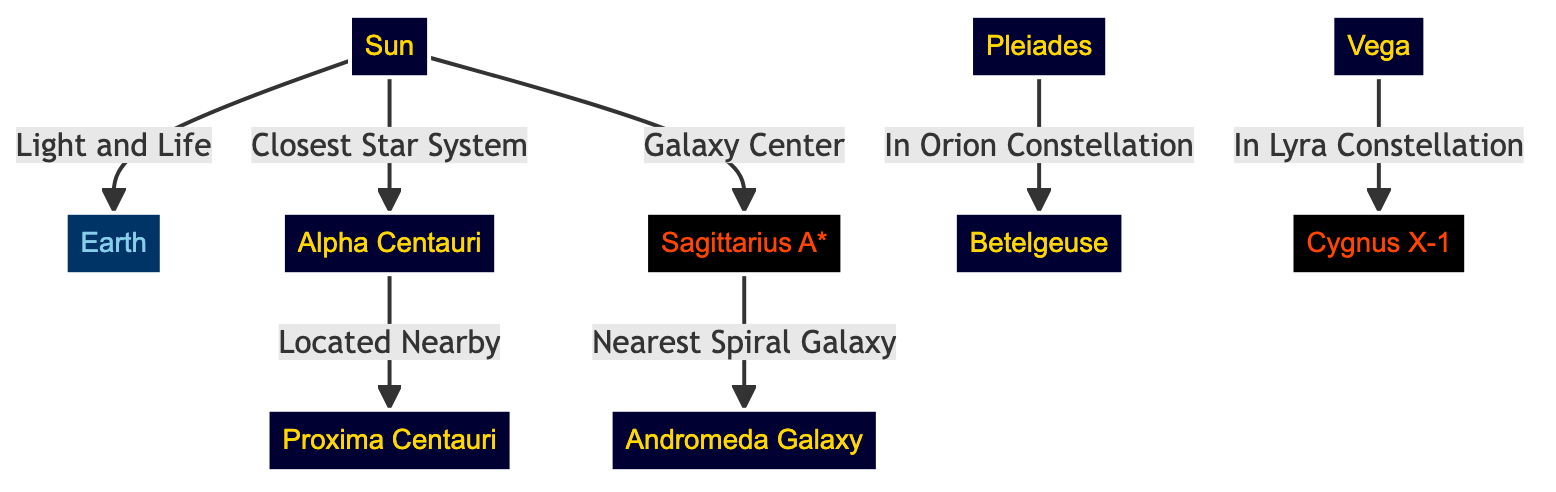What is at the center of the Milky Way? The diagram indicates that Sagittarius A* is the central object of the Milky Way, as shown by its direct connection to the Sun labeled "Galaxy Center." Therefore, the answer can be directly identified from this relationship.
Answer: Sagittarius A* Which celestial object is the closest star system to the Sun? In the diagram, Alpha Centauri is clearly connected to the Sun with the label "Closest Star System," indicating it is the nearest star system. Thus, the answer follows from that connection.
Answer: Alpha Centauri How many celestial landmarks are connected to the Sun? By analyzing the diagram visually, we can see that the Sun is linked to three distinct celestial landmarks: Earth, Alpha Centauri, and Sagittarius A*. Counting these connections gives us the total number of connections.
Answer: 3 What constellation is Betelgeuse part of? The diagram explicitly states that Betelgeuse is in the Orion Constellation, as shown in the connection labeled "In Orion Constellation". This can be directly noted from the information provided in the diagram.
Answer: Orion What is the relationship between Alpha Centauri and Proxima Centauri? The diagram illustrates that Alpha Centauri is "Located Nearby" to Proxima Centauri, indicating a close spatial relationship between the two star systems. Analyzing this connection gives us the nature of their relationship.
Answer: Located Nearby Which celestial body is described as the "Nearest Spiral Galaxy"? The diagram clearly connects Sagittarius A* to Andromeda with the label "Nearest Spiral Galaxy," making it evident that Andromeda is the celestial body referred to in this context. This simplifies our search for the answer.
Answer: Andromeda Which celestial object is linked to Cygnus X-1? The diagram shows that Cygnus X-1 is connected to Vega, labeled "In Lyra Constellation." Analyzing the diagram reveals this direct connection, making it straightforward to identify the celestial object linked to Cygnus X-1.
Answer: Vega What color represents the Black Hole entities in the diagram? The diagram classifies black holes such as Sagittarius A* and Cygnus X-1 with a specific color scheme. Since both are labeled as black holes, we can refer to the class definition, which designates black holes with a fill color of black.
Answer: Black 